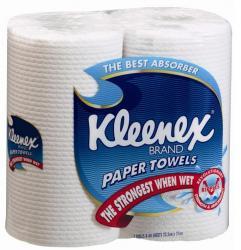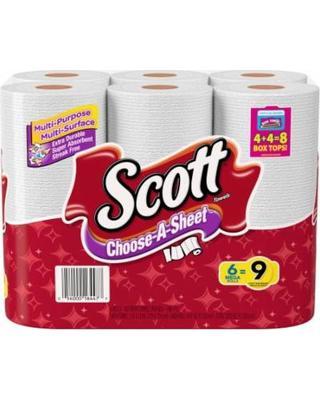The first image is the image on the left, the second image is the image on the right. Examine the images to the left and right. Is the description "In at least one image there is a 6 pack of scott paper towel sitting on a store shelve in mostly red packaging." accurate? Answer yes or no. No. The first image is the image on the left, the second image is the image on the right. Assess this claim about the two images: "The right image shows multipacks of paper towels on a store shelf, and includes a pack with the bottom half red.". Correct or not? Answer yes or no. No. 